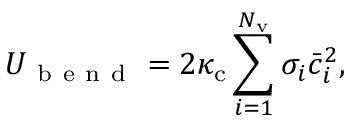Convert formula to latex. <formula><loc_0><loc_0><loc_500><loc_500>U _ { b e n d } = 2 \kappa _ { c } \sum _ { i = 1 } ^ { N _ { v } } \sigma _ { i } \bar { c } _ { i } ^ { 2 } ,</formula> 